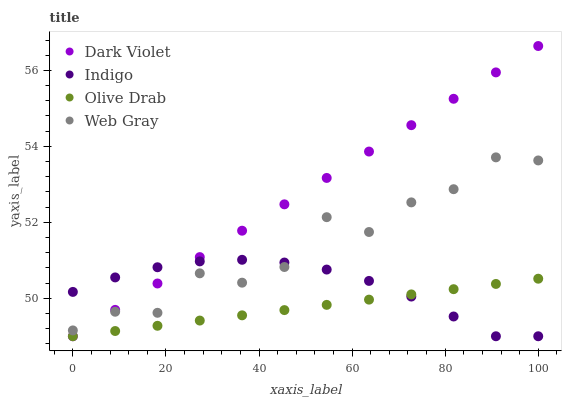Does Olive Drab have the minimum area under the curve?
Answer yes or no. Yes. Does Dark Violet have the maximum area under the curve?
Answer yes or no. Yes. Does Indigo have the minimum area under the curve?
Answer yes or no. No. Does Indigo have the maximum area under the curve?
Answer yes or no. No. Is Olive Drab the smoothest?
Answer yes or no. Yes. Is Web Gray the roughest?
Answer yes or no. Yes. Is Indigo the smoothest?
Answer yes or no. No. Is Indigo the roughest?
Answer yes or no. No. Does Indigo have the lowest value?
Answer yes or no. Yes. Does Dark Violet have the highest value?
Answer yes or no. Yes. Does Indigo have the highest value?
Answer yes or no. No. Is Olive Drab less than Web Gray?
Answer yes or no. Yes. Is Web Gray greater than Olive Drab?
Answer yes or no. Yes. Does Web Gray intersect Dark Violet?
Answer yes or no. Yes. Is Web Gray less than Dark Violet?
Answer yes or no. No. Is Web Gray greater than Dark Violet?
Answer yes or no. No. Does Olive Drab intersect Web Gray?
Answer yes or no. No. 